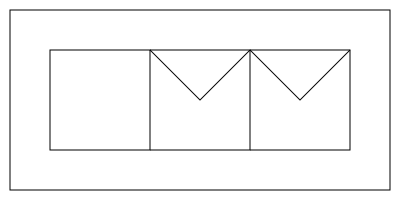Your child is working on a 3D shapes project for their AEC (Architecture, Engineering, and Construction) class. They show you this 2D net and ask which 3D shape it would form when folded. What shape should you tell them it will create? Let's analyze this 2D net step-by-step:

1. The net consists of three rectangles in a row and two triangles on top of the second and third rectangles.

2. When folded, the three rectangles will form the sides of a prism.

3. The two triangles will fold to create the sloped top of the shape.

4. The absence of a bottom face indicates that this shape will be open on one end.

5. The rectangular base and triangular sides forming a sloped top are characteristic of a right triangular prism.

6. However, since one end (the bottom) is missing, this specific shape is not a complete prism.

7. The correct term for this shape is a "triangular prism without one base" or an "open triangular prism."

This shape is commonly seen in architecture and construction, often used for roof structures or decorative elements, which makes it relevant to your child's AEC studies.
Answer: Open triangular prism 